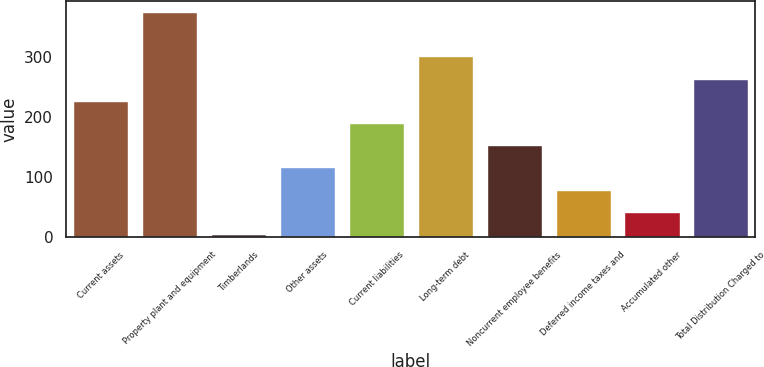<chart> <loc_0><loc_0><loc_500><loc_500><bar_chart><fcel>Current assets<fcel>Property plant and equipment<fcel>Timberlands<fcel>Other assets<fcel>Current liabilities<fcel>Long-term debt<fcel>Noncurrent employee benefits<fcel>Deferred income taxes and<fcel>Accumulated other<fcel>Total Distribution Charged to<nl><fcel>227.36<fcel>375.4<fcel>5.3<fcel>116.33<fcel>190.35<fcel>301.38<fcel>153.34<fcel>79.32<fcel>42.31<fcel>264.37<nl></chart> 